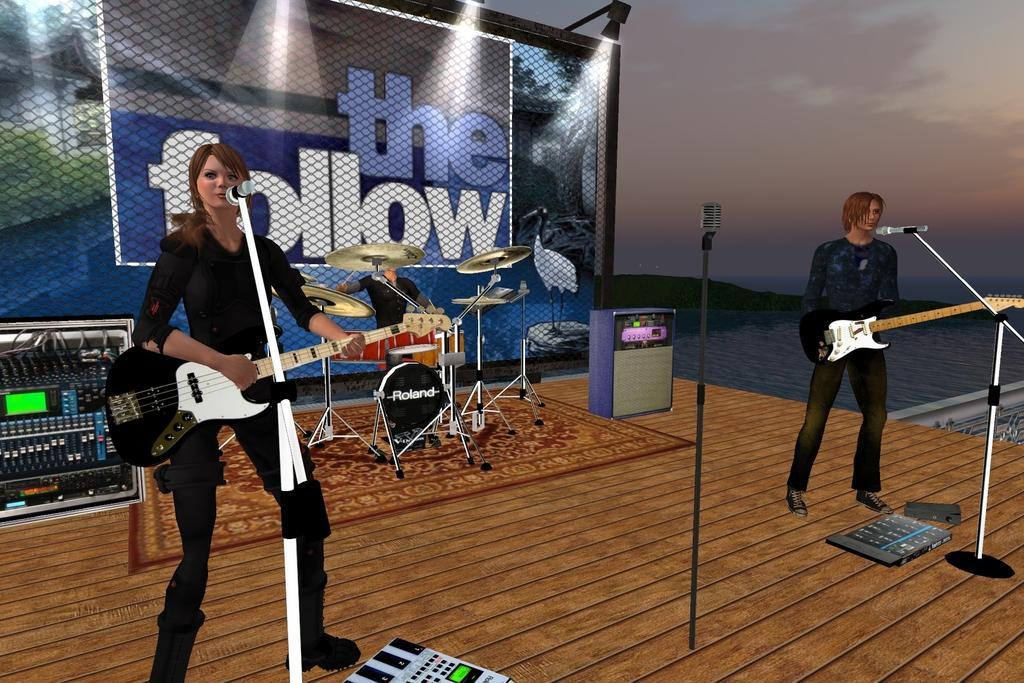Can you describe this image briefly? This is an animated picture. Here we can see two persons playing guitars. There are mike's, musical instruments, and a person sitting on the chair. In the background we can see a mesh, banner, water, and sky. 